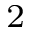Convert formula to latex. <formula><loc_0><loc_0><loc_500><loc_500>^ { 2 }</formula> 